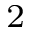Convert formula to latex. <formula><loc_0><loc_0><loc_500><loc_500>^ { 2 }</formula> 